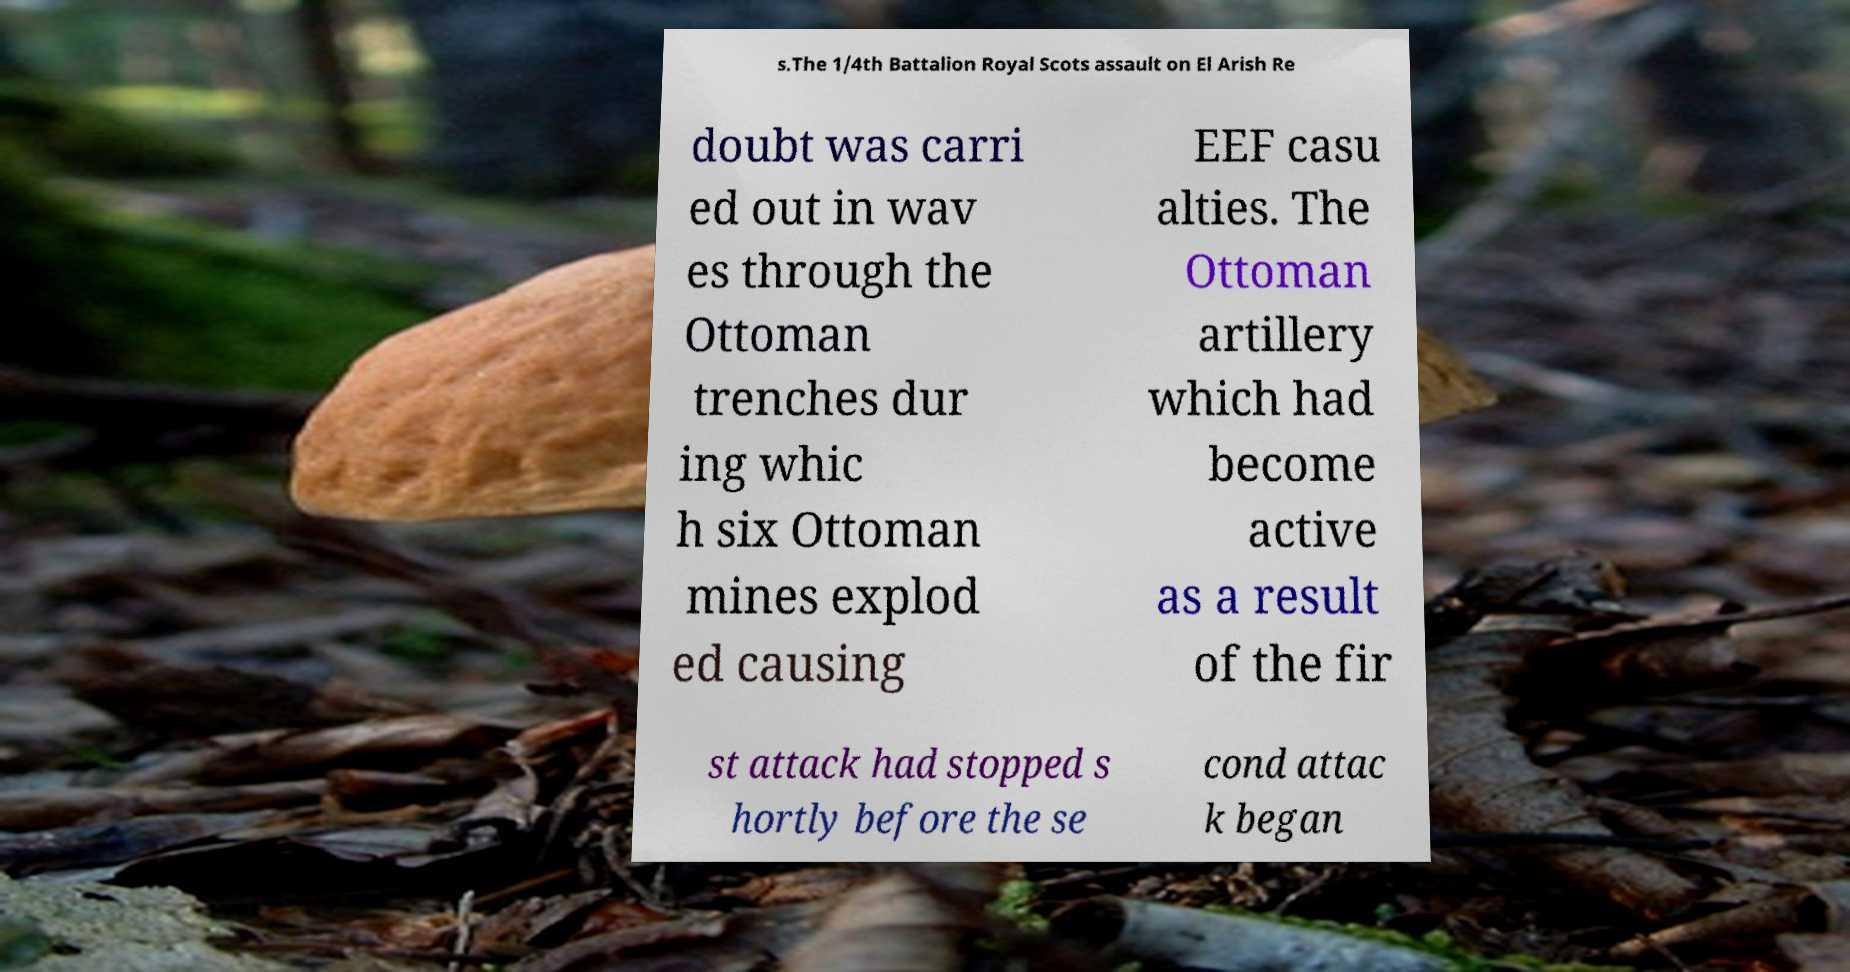Please read and relay the text visible in this image. What does it say? s.The 1/4th Battalion Royal Scots assault on El Arish Re doubt was carri ed out in wav es through the Ottoman trenches dur ing whic h six Ottoman mines explod ed causing EEF casu alties. The Ottoman artillery which had become active as a result of the fir st attack had stopped s hortly before the se cond attac k began 